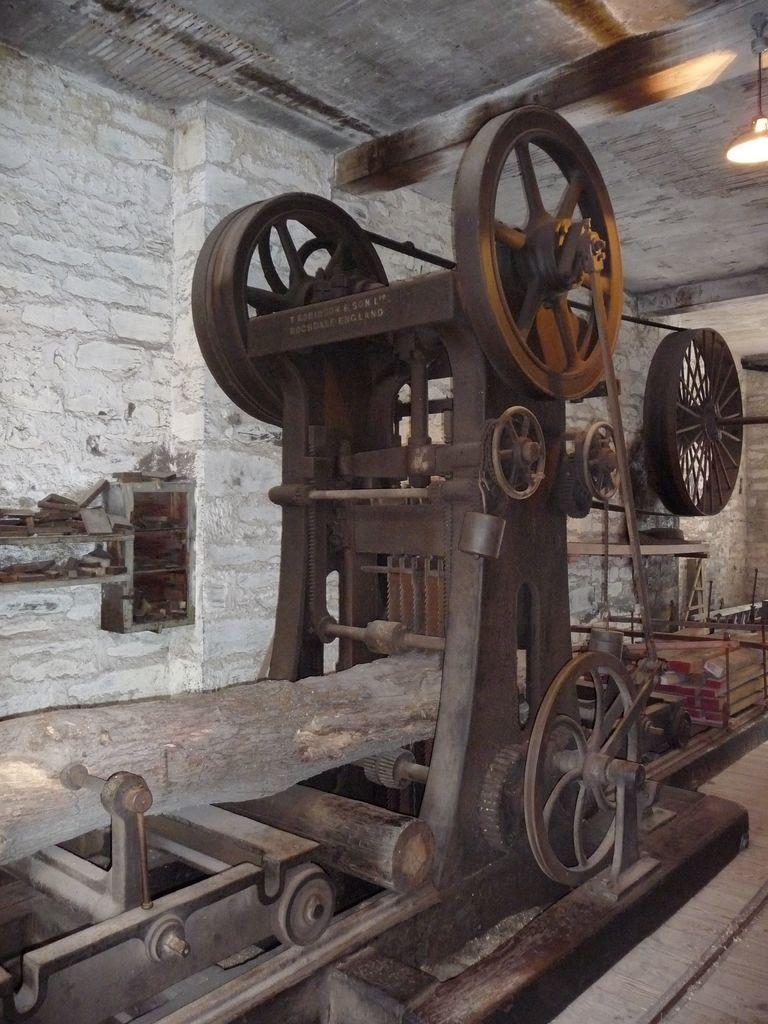How would you summarize this image in a sentence or two? In the picture I can see a machine. In the background I can see a wall, lights on the ceiling and some other objects. 